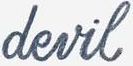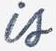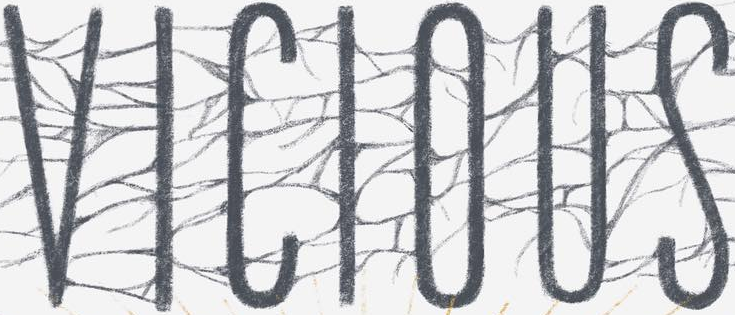What words are shown in these images in order, separated by a semicolon? devil; is; VICIOUS 